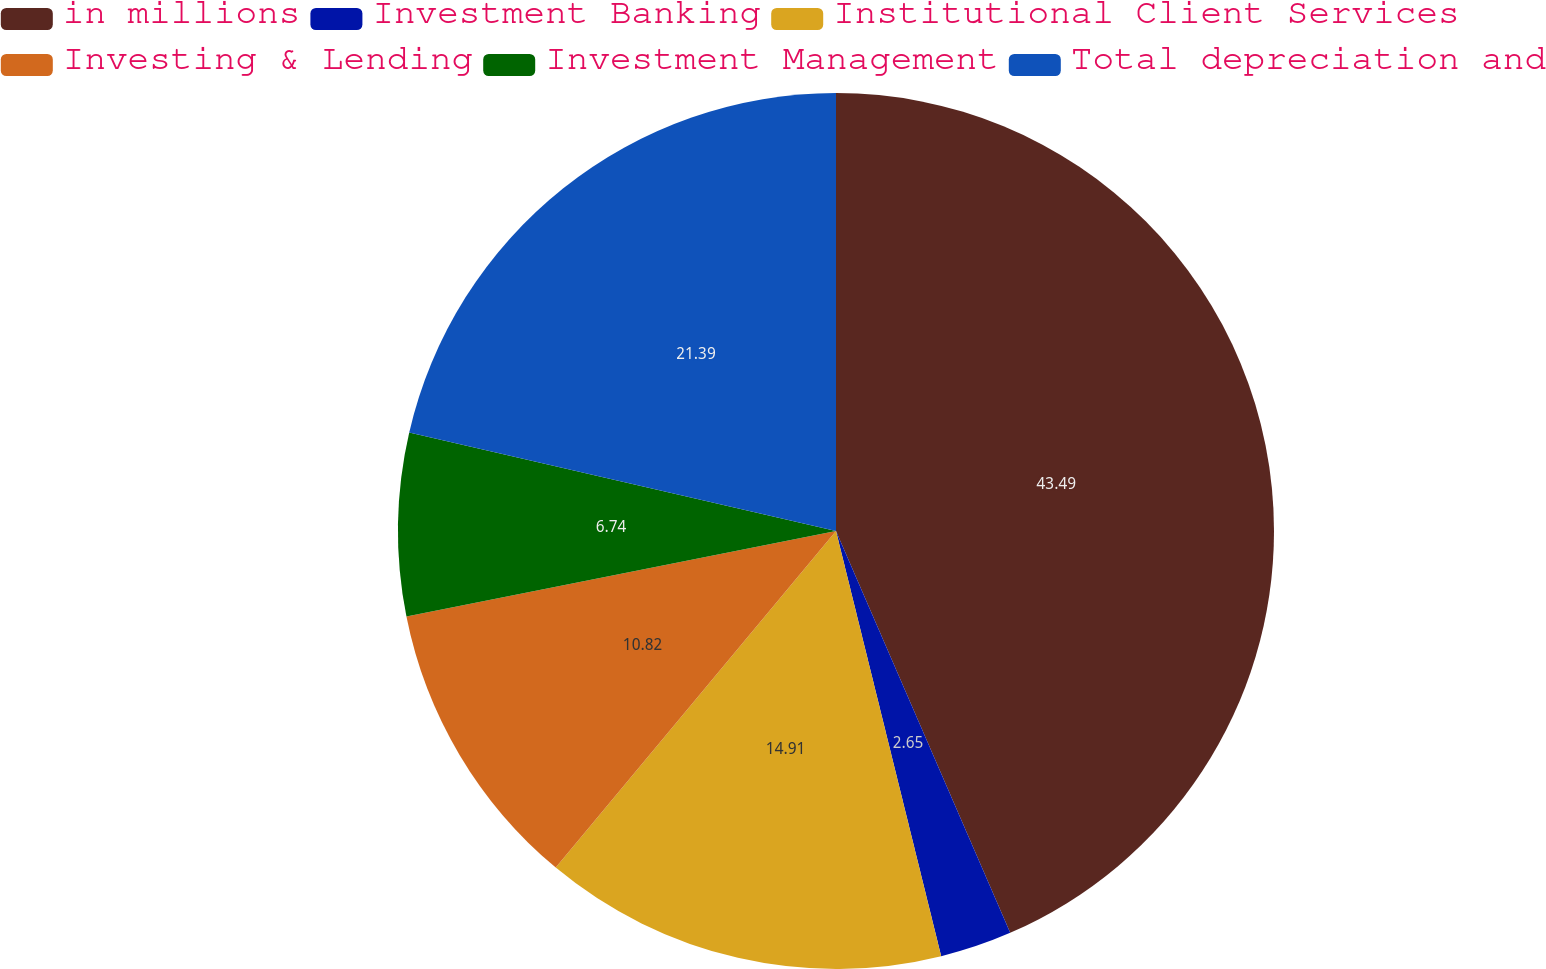Convert chart to OTSL. <chart><loc_0><loc_0><loc_500><loc_500><pie_chart><fcel>in millions<fcel>Investment Banking<fcel>Institutional Client Services<fcel>Investing & Lending<fcel>Investment Management<fcel>Total depreciation and<nl><fcel>43.49%<fcel>2.65%<fcel>14.91%<fcel>10.82%<fcel>6.74%<fcel>21.39%<nl></chart> 